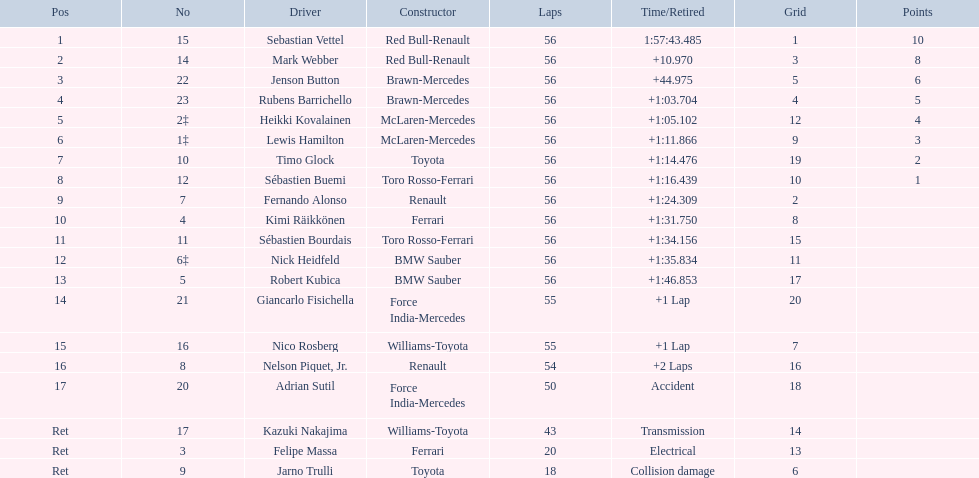Who were all the participants? Sebastian Vettel, Mark Webber, Jenson Button, Rubens Barrichello, Heikki Kovalainen, Lewis Hamilton, Timo Glock, Sébastien Buemi, Fernando Alonso, Kimi Räikkönen, Sébastien Bourdais, Nick Heidfeld, Robert Kubica, Giancarlo Fisichella, Nico Rosberg, Nelson Piquet, Jr., Adrian Sutil, Kazuki Nakajima, Felipe Massa, Jarno Trulli. Which of these didn't have ferrari as a manufacturer? Sebastian Vettel, Mark Webber, Jenson Button, Rubens Barrichello, Heikki Kovalainen, Lewis Hamilton, Timo Glock, Sébastien Buemi, Fernando Alonso, Sébastien Bourdais, Nick Heidfeld, Robert Kubica, Giancarlo Fisichella, Nico Rosberg, Nelson Piquet, Jr., Adrian Sutil, Kazuki Nakajima, Jarno Trulli. Which of these was in the foremost rank? Sebastian Vettel. 